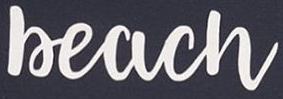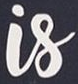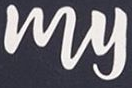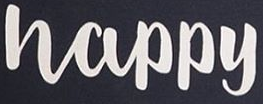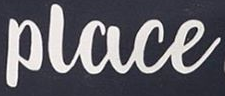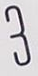Read the text content from these images in order, separated by a semicolon. Beach; Is; My; Happy; Place; 3 